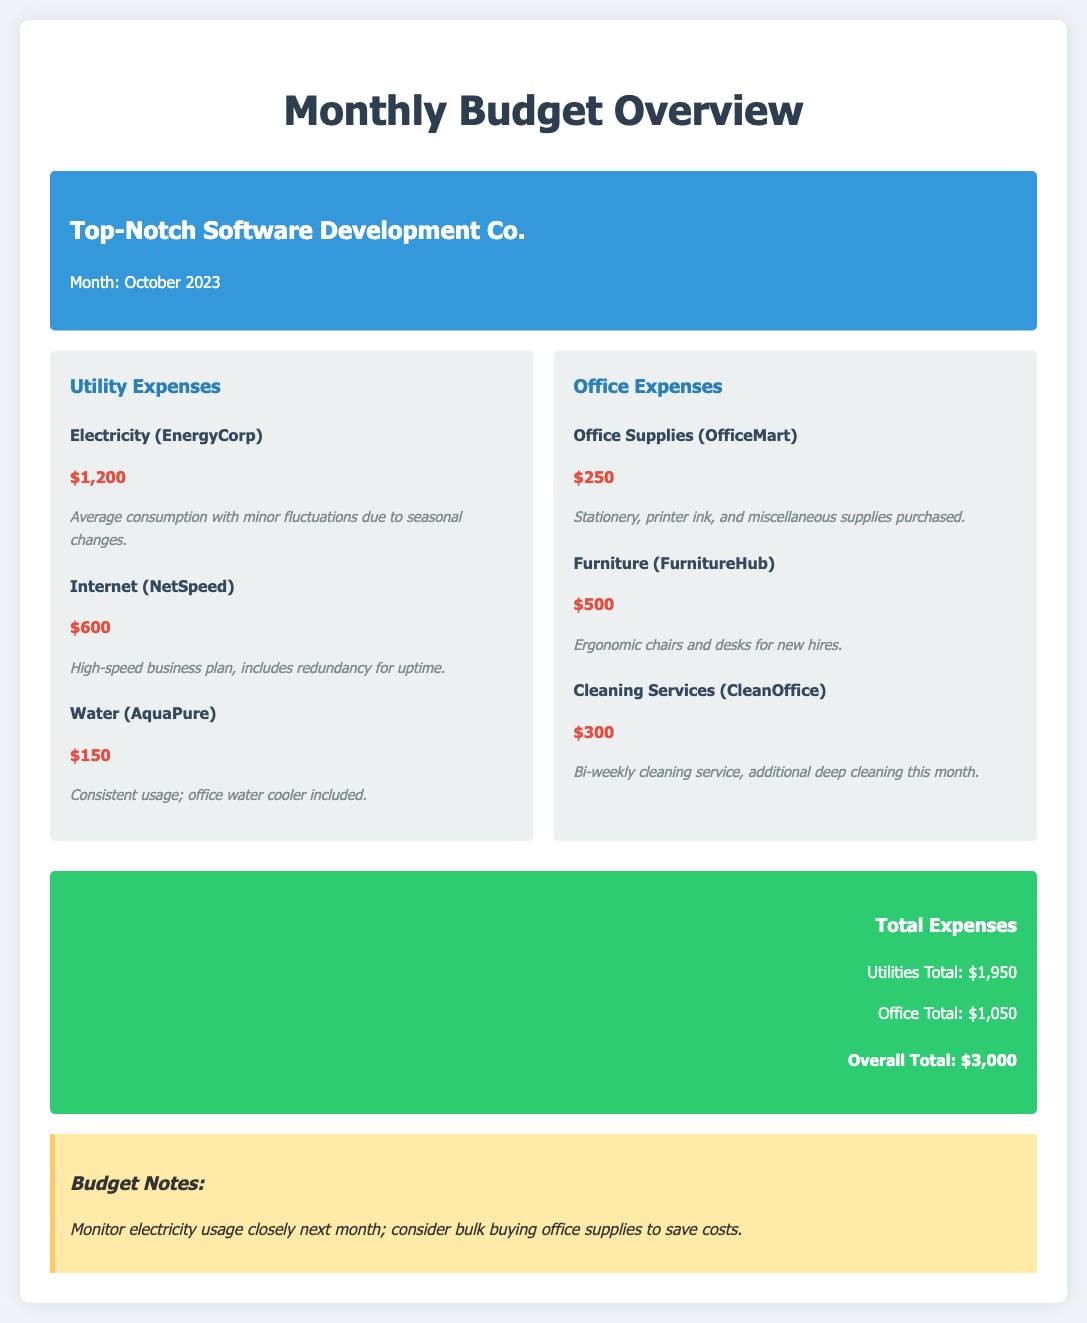What is the total amount spent on electricity? The electricity expense is detailed in the document as $1,200.
Answer: $1,200 What is the total expenditure for office supplies? The office supplies expense is listed as $250 in the office expenses section.
Answer: $250 Which company provides the internet service? The internet service provider is indicated as NetSpeed in the utility expenses section.
Answer: NetSpeed How much is spent on cleaning services? The cleaning service expense is specified as $300 in the office expenses category.
Answer: $300 What is the total amount spent on utilities? The utilities total is computed as the sum of electricity, internet, and water expenses, which equals $1,950.
Answer: $1,950 Which new furniture was purchased for the office? The document mentions the purchase of ergonomic chairs and desks for new hires under furniture expenses.
Answer: Ergonomic chairs and desks What month does this budget overview pertain to? The budget overview is stated to be for the month of October 2023.
Answer: October 2023 What is the overall total expenses for the month? The overall total expenses are presented as $3,000 in the totals section.
Answer: $3,000 What does the budget note suggest regarding electricity usage? The budget note indicates to monitor electricity usage closely next month.
Answer: Monitor electricity usage closely What was the additional service provided by the cleaning company this month? The document notes that there was additional deep cleaning performed this month by the cleaning service.
Answer: Additional deep cleaning 